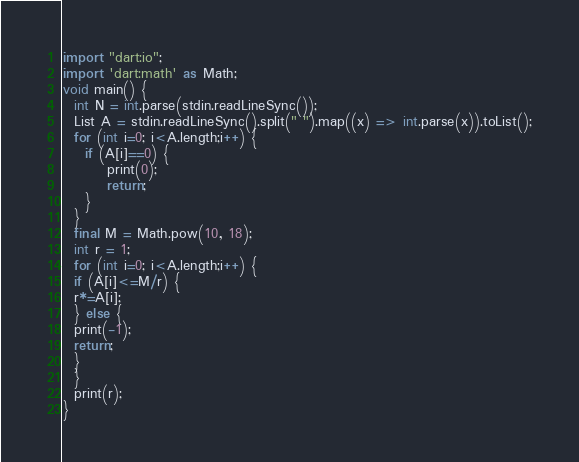Convert code to text. <code><loc_0><loc_0><loc_500><loc_500><_Dart_>import "dart:io";
import 'dart:math' as Math;
void main() {
  int N = int.parse(stdin.readLineSync());
  List A = stdin.readLineSync().split(" ").map((x) => int.parse(x)).toList();
  for (int i=0; i<A.length;i++) {
  	if (A[i]==0) {
    	print(0);
        return;
    }
  }
  final M = Math.pow(10, 18);
  int r = 1;
  for (int i=0; i<A.length;i++) {
  if (A[i]<=M/r) {
  r*=A[i];
  } else {
  print(-1);
  return;
  }
  }
  print(r);
}
</code> 